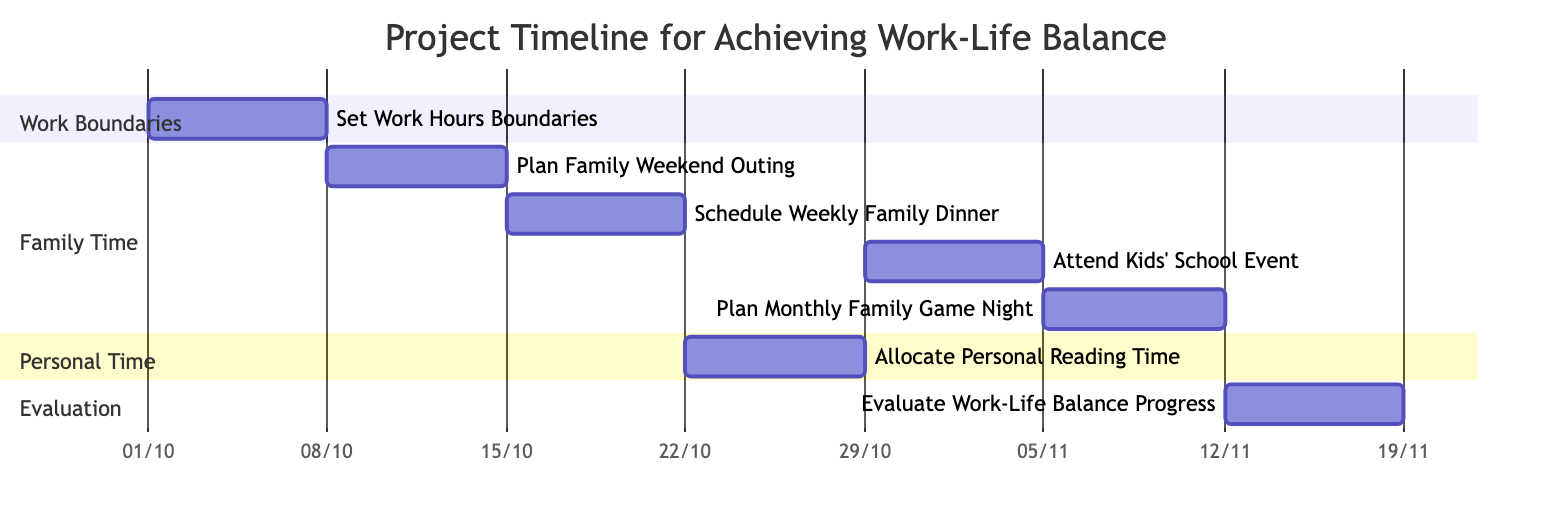What is the duration of the "Set Work Hours Boundaries" task? The task "Set Work Hours Boundaries" spans from October 1, 2023, to October 7, 2023, which is a total of 7 days.
Answer: 7 days How many tasks are in the "Family Time" section? The "Family Time" section has four tasks: "Plan Family Weekend Outing," "Schedule Weekly Family Dinner," "Attend Kids' School Event," and "Plan Monthly Family Game Night." Counting these gives a total of 4 tasks.
Answer: 4 tasks What task is allocated to the week starting on October 22, 2023? Looking at the timeline, the task scheduled for the week starting October 22, 2023, is "Allocate Personal Reading Time," which runs from October 22 to October 28.
Answer: Allocate Personal Reading Time Which task starts right after the "Schedule Weekly Family Dinner"? The "Schedule Weekly Family Dinner" ends on October 21, 2023. The next task, starting immediately after, is "Allocate Personal Reading Time," which begins on October 22, 2023.
Answer: Allocate Personal Reading Time When does the "Evaluate Work-Life Balance Progress" task begin? The task "Evaluate Work-Life Balance Progress" starts on November 12, 2023, as indicated in the diagram.
Answer: November 12, 2023 Which tasks overlap in their scheduling? The tasks "Plan Monthly Family Game Night" and "Evaluate Work-Life Balance Progress" have overlapping timeframes. "Plan Monthly Family Game Night" runs from November 5 to November 11, while "Evaluate Work-Life Balance Progress" starts on November 12. There is no overlap since they do not share any days. Thus, they are consecutive, not overlapping.
Answer: No overlapping tasks What section does the task "Attend Kids' School Event" belong to? The task "Attend Kids' School Event" is listed in the "Family Time" section of the Gantt Chart, which includes various family-oriented activities.
Answer: Family Time What is the total number of tasks listed in the Gantt Chart? There are seven distinct tasks in the Gantt Chart, encompassing various aspects of work-life balance initiatives. Adding them up leads to the total: Set Work Hours Boundaries, Plan Family Weekend Outing, Schedule Weekly Family Dinner, Allocate Personal Reading Time, Attend Kids' School Event, Plan Monthly Family Game Night, and Evaluate Work-Life Balance Progress.
Answer: 7 tasks 